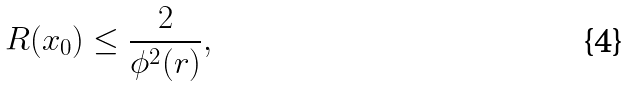<formula> <loc_0><loc_0><loc_500><loc_500>R ( x _ { 0 } ) \leq \frac { 2 } { \phi ^ { 2 } ( r ) } ,</formula> 